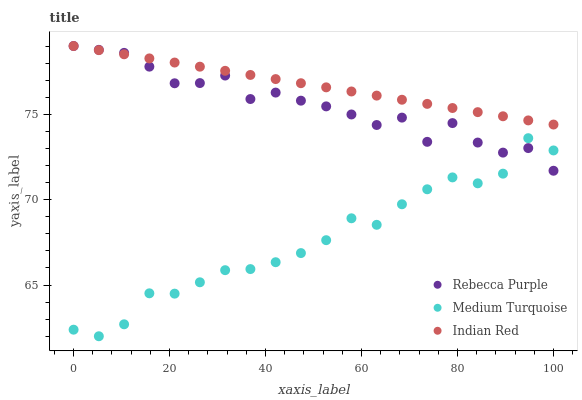Does Medium Turquoise have the minimum area under the curve?
Answer yes or no. Yes. Does Indian Red have the maximum area under the curve?
Answer yes or no. Yes. Does Rebecca Purple have the minimum area under the curve?
Answer yes or no. No. Does Rebecca Purple have the maximum area under the curve?
Answer yes or no. No. Is Indian Red the smoothest?
Answer yes or no. Yes. Is Rebecca Purple the roughest?
Answer yes or no. Yes. Is Medium Turquoise the smoothest?
Answer yes or no. No. Is Medium Turquoise the roughest?
Answer yes or no. No. Does Medium Turquoise have the lowest value?
Answer yes or no. Yes. Does Rebecca Purple have the lowest value?
Answer yes or no. No. Does Rebecca Purple have the highest value?
Answer yes or no. Yes. Does Medium Turquoise have the highest value?
Answer yes or no. No. Is Medium Turquoise less than Indian Red?
Answer yes or no. Yes. Is Indian Red greater than Medium Turquoise?
Answer yes or no. Yes. Does Indian Red intersect Rebecca Purple?
Answer yes or no. Yes. Is Indian Red less than Rebecca Purple?
Answer yes or no. No. Is Indian Red greater than Rebecca Purple?
Answer yes or no. No. Does Medium Turquoise intersect Indian Red?
Answer yes or no. No. 